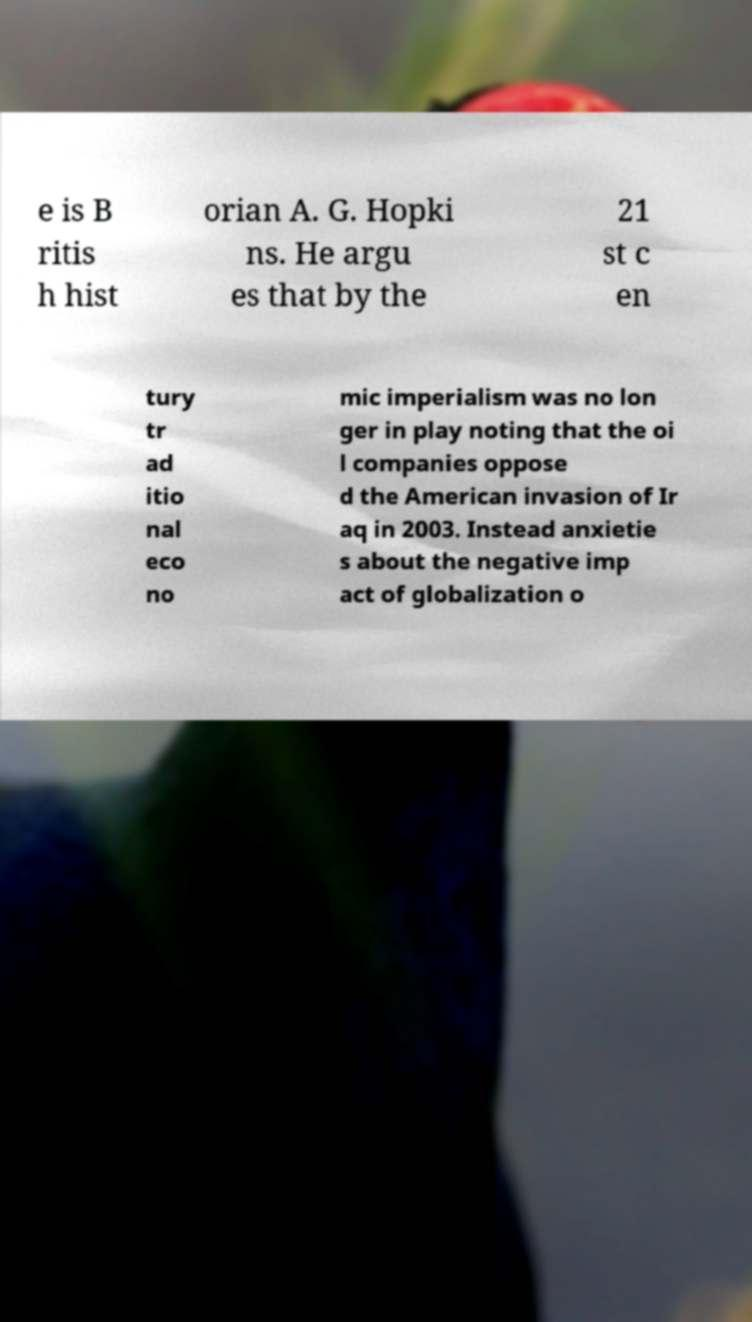Can you read and provide the text displayed in the image?This photo seems to have some interesting text. Can you extract and type it out for me? e is B ritis h hist orian A. G. Hopki ns. He argu es that by the 21 st c en tury tr ad itio nal eco no mic imperialism was no lon ger in play noting that the oi l companies oppose d the American invasion of Ir aq in 2003. Instead anxietie s about the negative imp act of globalization o 